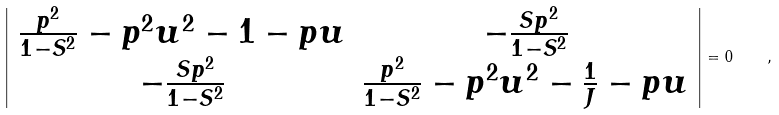Convert formula to latex. <formula><loc_0><loc_0><loc_500><loc_500>\left | \begin{array} { c c } \frac { p ^ { 2 } } { 1 - S ^ { 2 } } - p ^ { 2 } u ^ { 2 } - 1 - p u & - \frac { S p ^ { 2 } } { 1 - S ^ { 2 } } \\ - \frac { S p ^ { 2 } } { 1 - S ^ { 2 } } & \frac { p ^ { 2 } } { 1 - S ^ { 2 } } - p ^ { 2 } u ^ { 2 } - \frac { 1 } { J } - p u \end{array} \right | = 0 \quad ,</formula> 